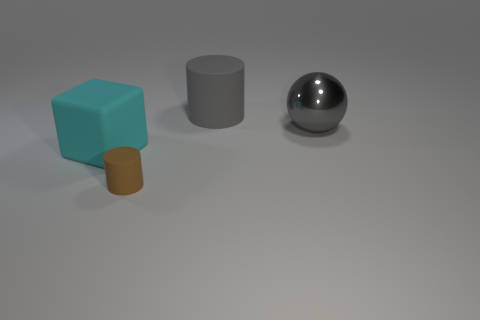How big is the cylinder that is in front of the gray object that is on the left side of the metallic ball?
Your answer should be very brief. Small. There is a rubber object that is on the right side of the cyan rubber block and behind the tiny brown cylinder; what color is it?
Provide a short and direct response. Gray. There is a ball that is the same size as the cyan thing; what material is it?
Your response must be concise. Metal. What number of other things are there of the same material as the brown thing
Offer a terse response. 2. There is a matte cylinder that is behind the cyan rubber cube; is its color the same as the rubber object that is in front of the cyan object?
Your answer should be compact. No. What is the shape of the big matte object that is in front of the rubber thing that is behind the cube?
Provide a succinct answer. Cube. What number of other things are the same color as the rubber cube?
Keep it short and to the point. 0. Does the cylinder behind the matte block have the same material as the object on the left side of the brown cylinder?
Keep it short and to the point. Yes. How big is the gray rubber cylinder that is behind the large gray metal sphere?
Your answer should be very brief. Large. What is the material of the gray object that is the same shape as the tiny brown rubber object?
Give a very brief answer. Rubber. 